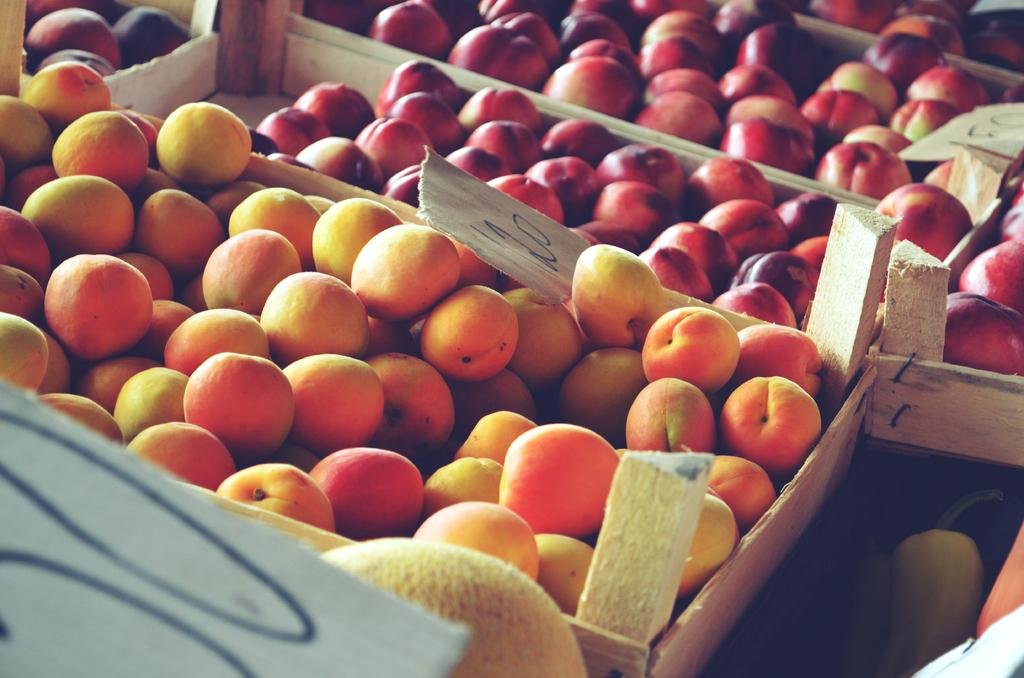What type of containers are present in the image? There are wooden boxes in the image. What is inside the wooden boxes? There are red color apples and yellow color fruits in the boxes. How does the brake system work in the wooden boxes? There is no brake system present in the wooden boxes, as they are not vehicles or machinery. 